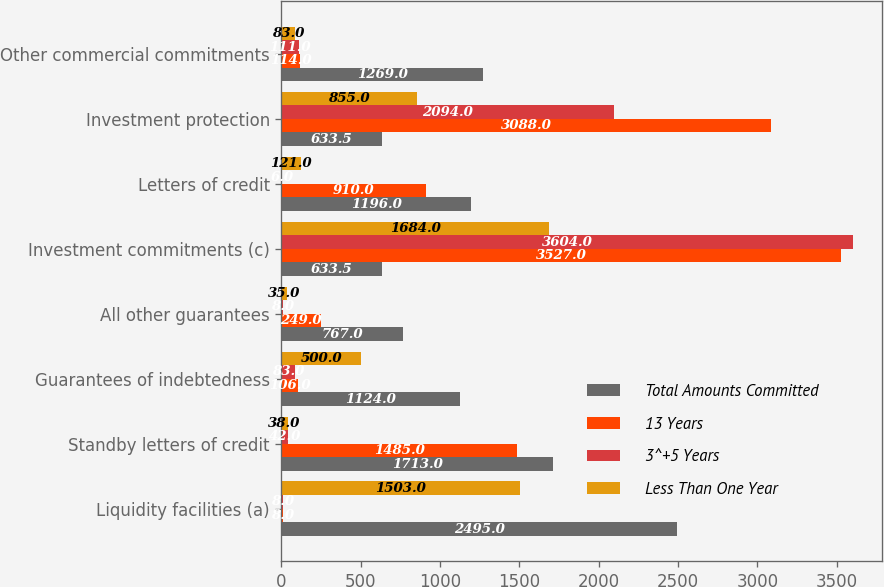Convert chart. <chart><loc_0><loc_0><loc_500><loc_500><stacked_bar_chart><ecel><fcel>Liquidity facilities (a)<fcel>Standby letters of credit<fcel>Guarantees of indebtedness<fcel>All other guarantees<fcel>Investment commitments (c)<fcel>Letters of credit<fcel>Investment protection<fcel>Other commercial commitments<nl><fcel>Total Amounts Committed<fcel>2495<fcel>1713<fcel>1124<fcel>767<fcel>633.5<fcel>1196<fcel>633.5<fcel>1269<nl><fcel>13 Years<fcel>8<fcel>1485<fcel>106<fcel>249<fcel>3527<fcel>910<fcel>3088<fcel>114<nl><fcel>3^+5 Years<fcel>8<fcel>42<fcel>83<fcel>8<fcel>3604<fcel>6<fcel>2094<fcel>111<nl><fcel>Less Than One Year<fcel>1503<fcel>38<fcel>500<fcel>35<fcel>1684<fcel>121<fcel>855<fcel>83<nl></chart> 